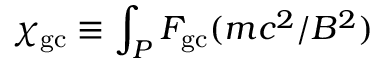<formula> <loc_0><loc_0><loc_500><loc_500>\chi _ { g c } \equiv \int _ { P } F _ { g c } ( m c ^ { 2 } / B ^ { 2 } )</formula> 